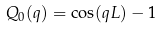<formula> <loc_0><loc_0><loc_500><loc_500>Q _ { 0 } ( q ) = \cos ( q L ) - 1</formula> 